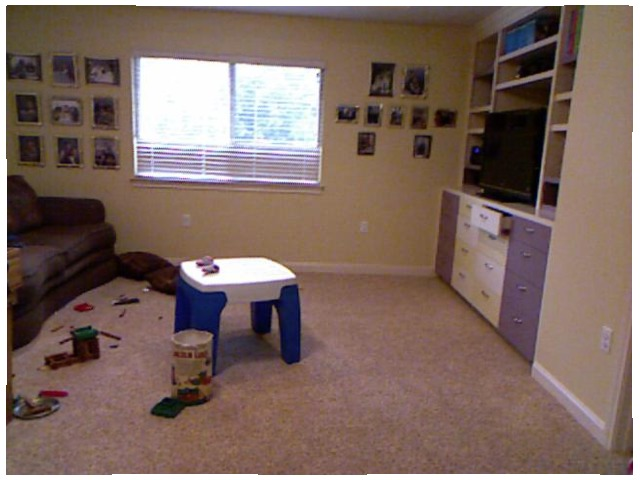<image>
Is there a sofa in front of the table? No. The sofa is not in front of the table. The spatial positioning shows a different relationship between these objects. Is the television above the drawer? Yes. The television is positioned above the drawer in the vertical space, higher up in the scene. Is there a toy on the floor? Yes. Looking at the image, I can see the toy is positioned on top of the floor, with the floor providing support. Where is the table in relation to the bin? Is it in the bin? No. The table is not contained within the bin. These objects have a different spatial relationship. Where is the window in relation to the chair? Is it behind the chair? Yes. From this viewpoint, the window is positioned behind the chair, with the chair partially or fully occluding the window. 